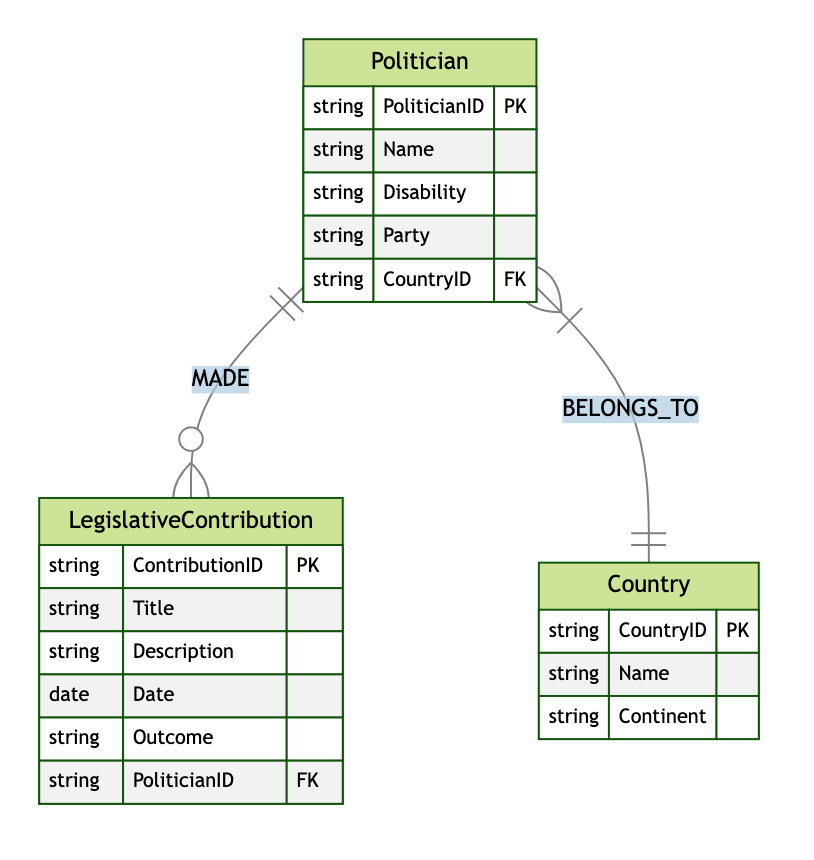What is the primary key of the Politician entity? The Politician entity has PoliticianID as its primary key, which uniquely identifies each politician in the entity.
Answer: PoliticianID How many attributes does the LegislativeContribution entity have? The LegislativeContribution entity has five attributes, which are ContributionID, Title, Description, Date, and Outcome.
Answer: 5 What relationship exists between the Politician and LegislativeContribution entities? The relationship between Politician and LegislativeContribution is named MADE, indicating that one politician can make multiple legislative contributions.
Answer: MADE How many countries are represented in the Country entity? The Country entity is represented by its unique CountryID, indicating each country can be linked to multiple politicians. The diagram doesn't specify an exact number of countries, but it suggests there can be many.
Answer: Many What is the foreign key in the LegislativeContribution entity? The foreign key in the LegislativeContribution entity is PoliticianID, linking contributions to the respective politician who made them.
Answer: PoliticianID Which entity has a many-to-one relationship with the Country entity? The Politician entity has a many-to-one relationship with the Country entity, meaning multiple politicians can belong to one country.
Answer: Politician How is the relationship between Politician and Country defined? The relationship between Politician and Country is defined as BELONGS_TO, indicating that a politician is associated with a particular country in the diagram.
Answer: BELONGS_TO Can a politician have multiple legislative contributions? Yes, according to the MADE relationship, a single politician can be associated with multiple legislative contributions, emphasizing their active role in legislation.
Answer: Yes What is an example of an attribute of the Country entity? An attribute of the Country entity includes Name, which represents the name of the country.
Answer: Name 